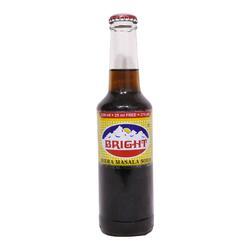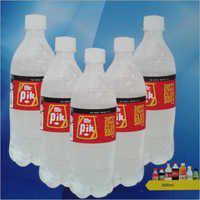The first image is the image on the left, the second image is the image on the right. Assess this claim about the two images: "There are at least seven bottles in total.". Correct or not? Answer yes or no. No. The first image is the image on the left, the second image is the image on the right. For the images shown, is this caption "One image shows five upright identical bottles arranged in a V-formation." true? Answer yes or no. Yes. 